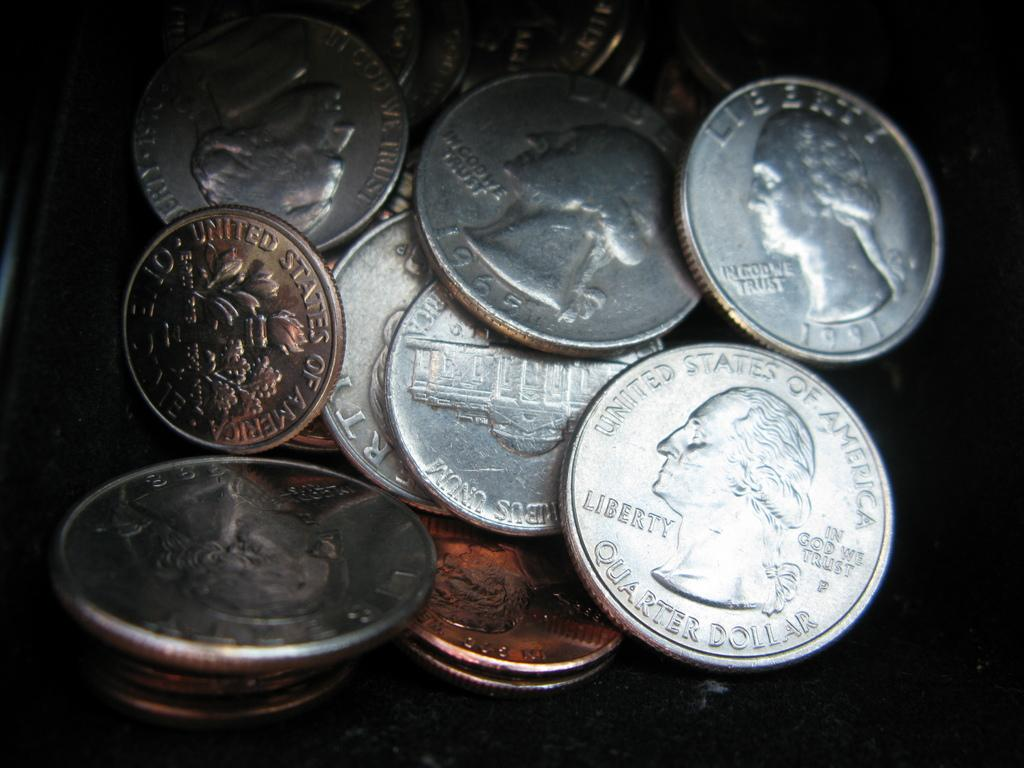<image>
Give a short and clear explanation of the subsequent image. A group of coins, one being the quarter from the United States of America. 